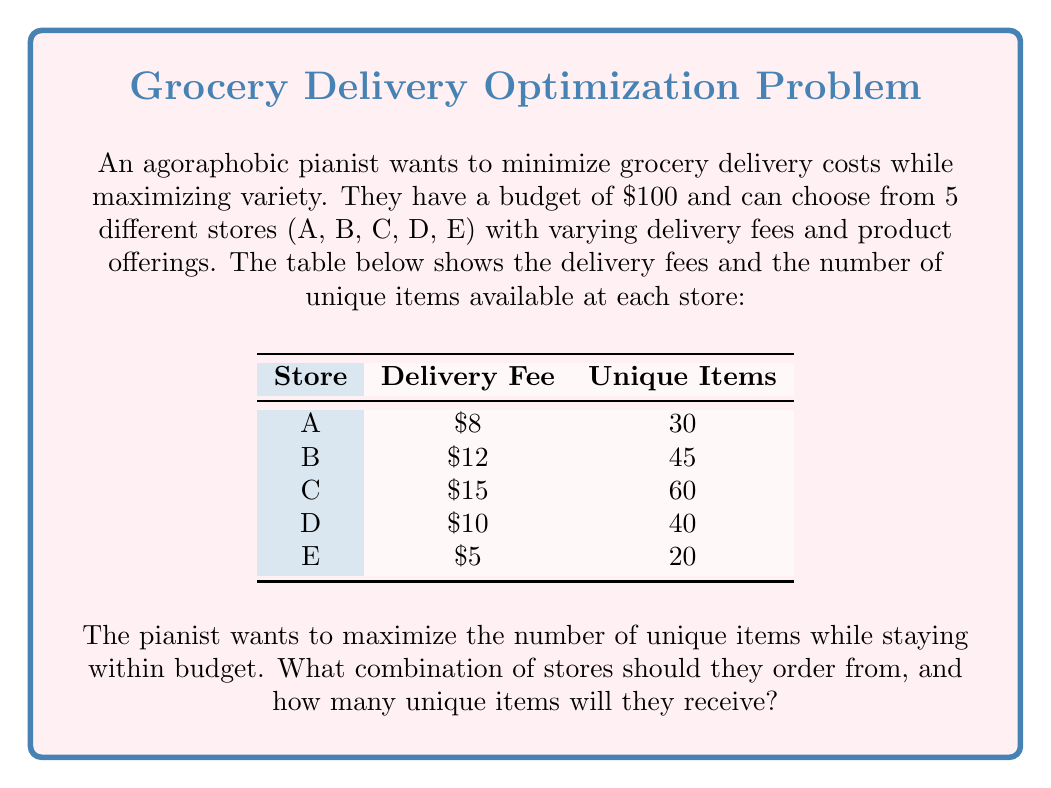Teach me how to tackle this problem. Let's approach this step-by-step:

1) First, we need to set up our optimization problem. Let $x_A, x_B, x_C, x_D, x_E$ be binary variables representing whether we order from each store (1) or not (0).

2) Our objective function is to maximize the number of unique items:

   $$\text{Maximize: } 30x_A + 45x_B + 60x_C + 40x_D + 20x_E$$

3) Our constraint is the budget of $100:

   $$8x_A + 12x_B + 15x_C + 10x_D + 5x_E \leq 100$$

4) Now, let's consider the stores in order of "efficiency" (unique items per dollar of delivery fee):

   A: 30/8 = 3.75
   B: 45/12 = 3.75
   C: 60/15 = 4
   D: 40/10 = 4
   E: 20/5 = 4

5) We should prioritize stores C, D, and E as they offer the most items per dollar of delivery fee.

6) Starting with C: 15 + 60 unique items
   Adding D: 15 + 10 = 25, 60 + 40 = 100 unique items
   Adding E: 25 + 5 = 30, 100 + 20 = 120 unique items

7) We've used $30 of our budget and have 120 unique items. We can't add A or B without exceeding the budget.

Therefore, the optimal solution is to order from stores C, D, and E.
Answer: Order from stores C, D, and E; receive 120 unique items 